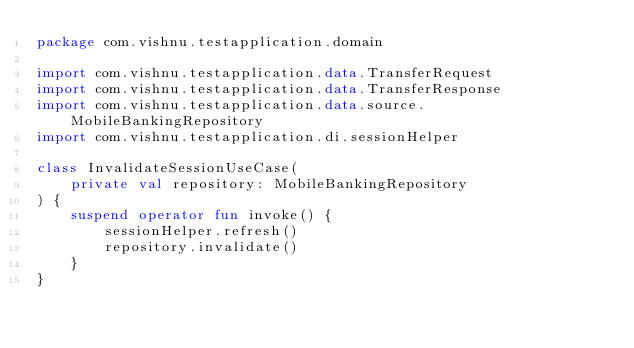<code> <loc_0><loc_0><loc_500><loc_500><_Kotlin_>package com.vishnu.testapplication.domain

import com.vishnu.testapplication.data.TransferRequest
import com.vishnu.testapplication.data.TransferResponse
import com.vishnu.testapplication.data.source.MobileBankingRepository
import com.vishnu.testapplication.di.sessionHelper

class InvalidateSessionUseCase(
    private val repository: MobileBankingRepository
) {
    suspend operator fun invoke() {
        sessionHelper.refresh()
        repository.invalidate()
    }
}</code> 